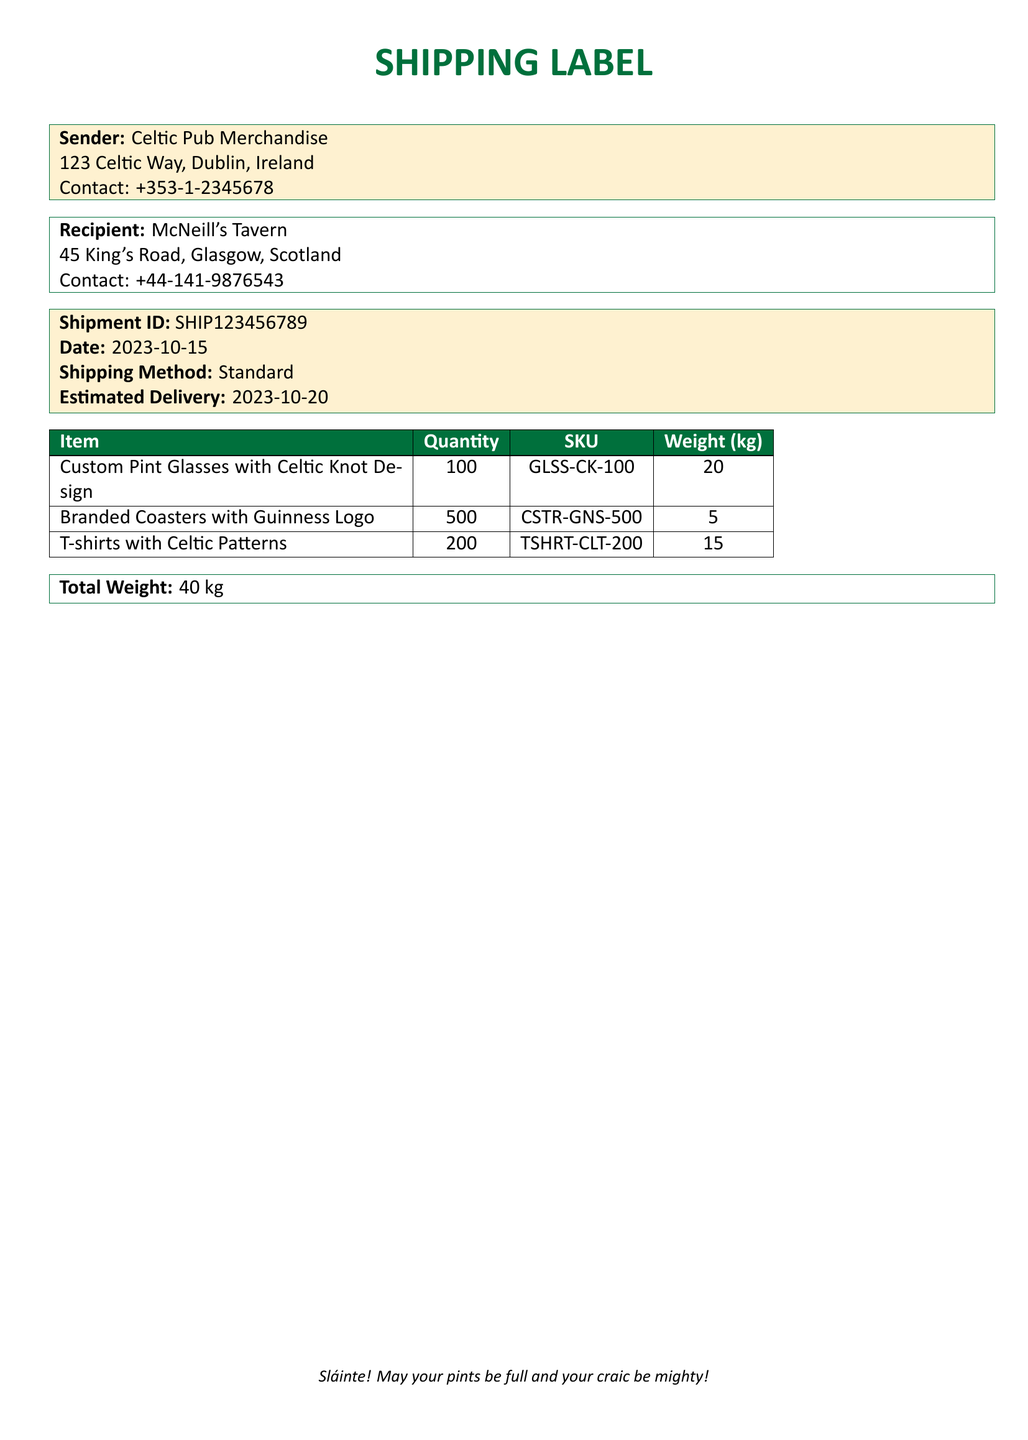What is the sender's address? The sender's address is listed in the document as "123 Celtic Way, Dublin, Ireland."
Answer: 123 Celtic Way, Dublin, Ireland What is the recipient's contact number? The recipient's contact number is provided in the document, which is "+44-141-9876543."
Answer: +44-141-9876543 What is the shipment ID? The shipment ID is explicitly mentioned in the document as "SHIP123456789."
Answer: SHIP123456789 How many T-shirts are included in the shipment? The document states the quantity of T-shirts included, which is 200.
Answer: 200 What is the total weight of the shipment? The total weight is summarized at the bottom of the document as "40 kg."
Answer: 40 kg What is the estimated delivery date? The estimated delivery date is detailed in the document as "2023-10-20."
Answer: 2023-10-20 What type of shipping method is used? The shipping method is specified in the document as "Standard."
Answer: Standard What is the SKU for the custom pint glasses? The document provides the SKU for custom pint glasses as "GLSS-CK-100."
Answer: GLSS-CK-100 